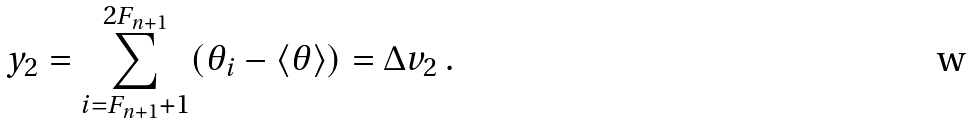<formula> <loc_0><loc_0><loc_500><loc_500>y _ { 2 } = \sum _ { i = F _ { n + 1 } + 1 } ^ { 2 F _ { n + 1 } } ( \theta _ { i } - \langle \theta \rangle ) = \Delta v _ { 2 } \, .</formula> 